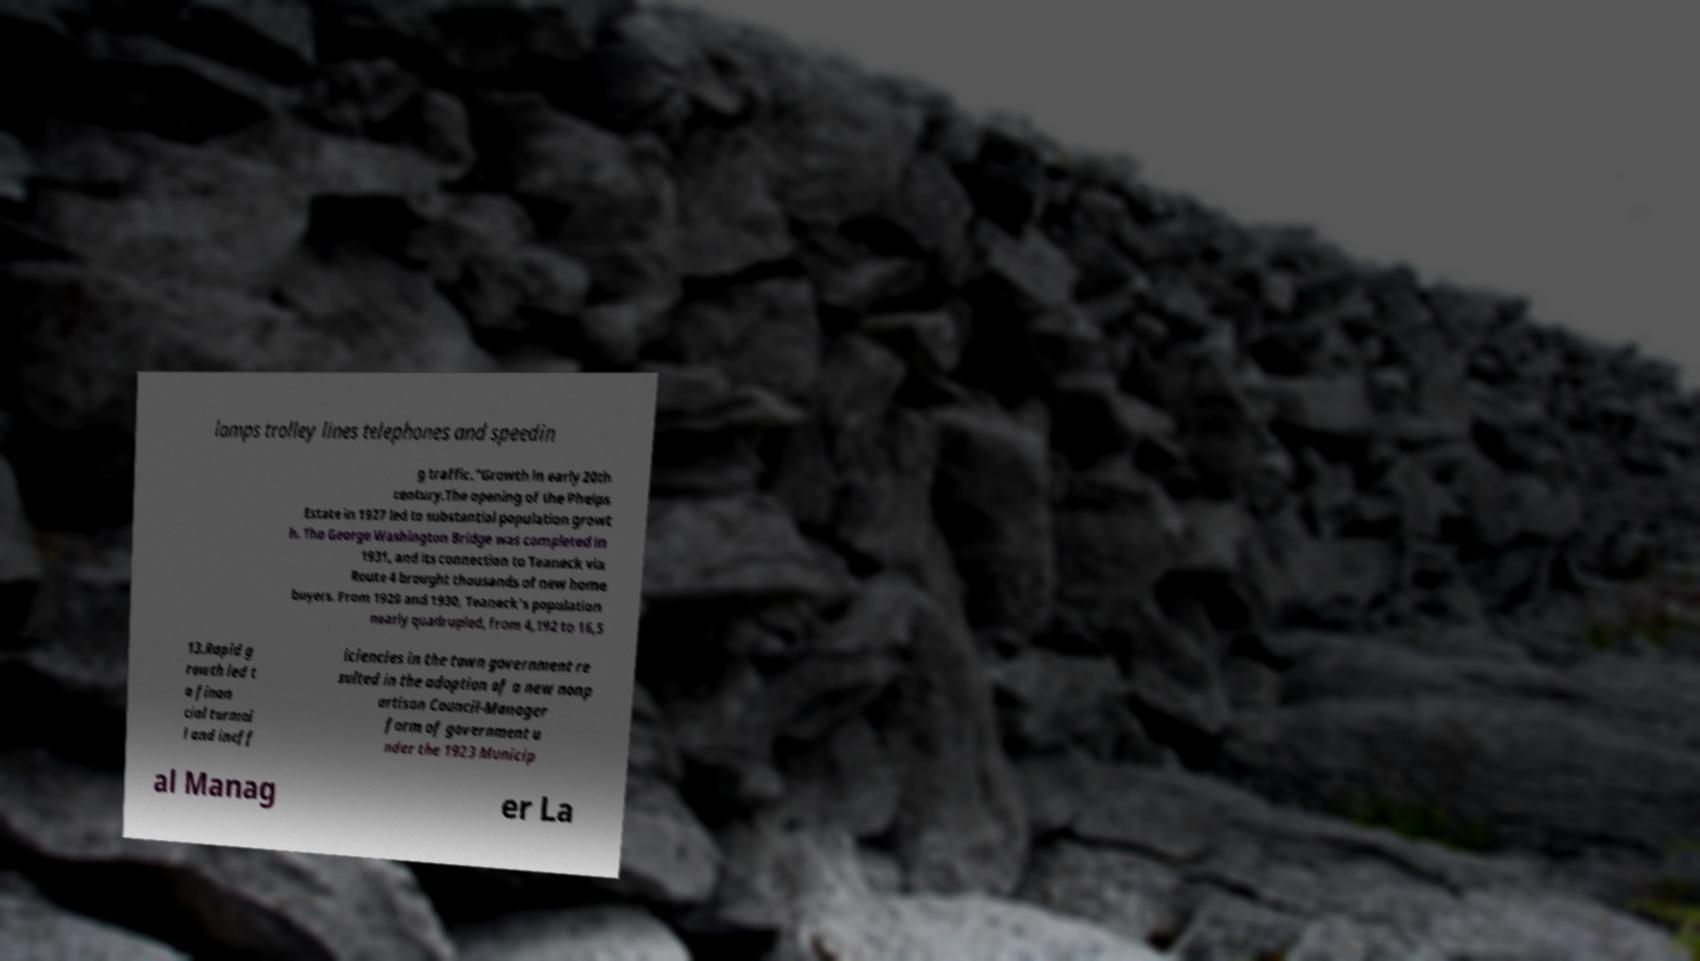Can you read and provide the text displayed in the image?This photo seems to have some interesting text. Can you extract and type it out for me? lamps trolley lines telephones and speedin g traffic."Growth in early 20th century.The opening of the Phelps Estate in 1927 led to substantial population growt h. The George Washington Bridge was completed in 1931, and its connection to Teaneck via Route 4 brought thousands of new home buyers. From 1920 and 1930, Teaneck's population nearly quadrupled, from 4,192 to 16,5 13.Rapid g rowth led t o finan cial turmoi l and ineff iciencies in the town government re sulted in the adoption of a new nonp artisan Council-Manager form of government u nder the 1923 Municip al Manag er La 